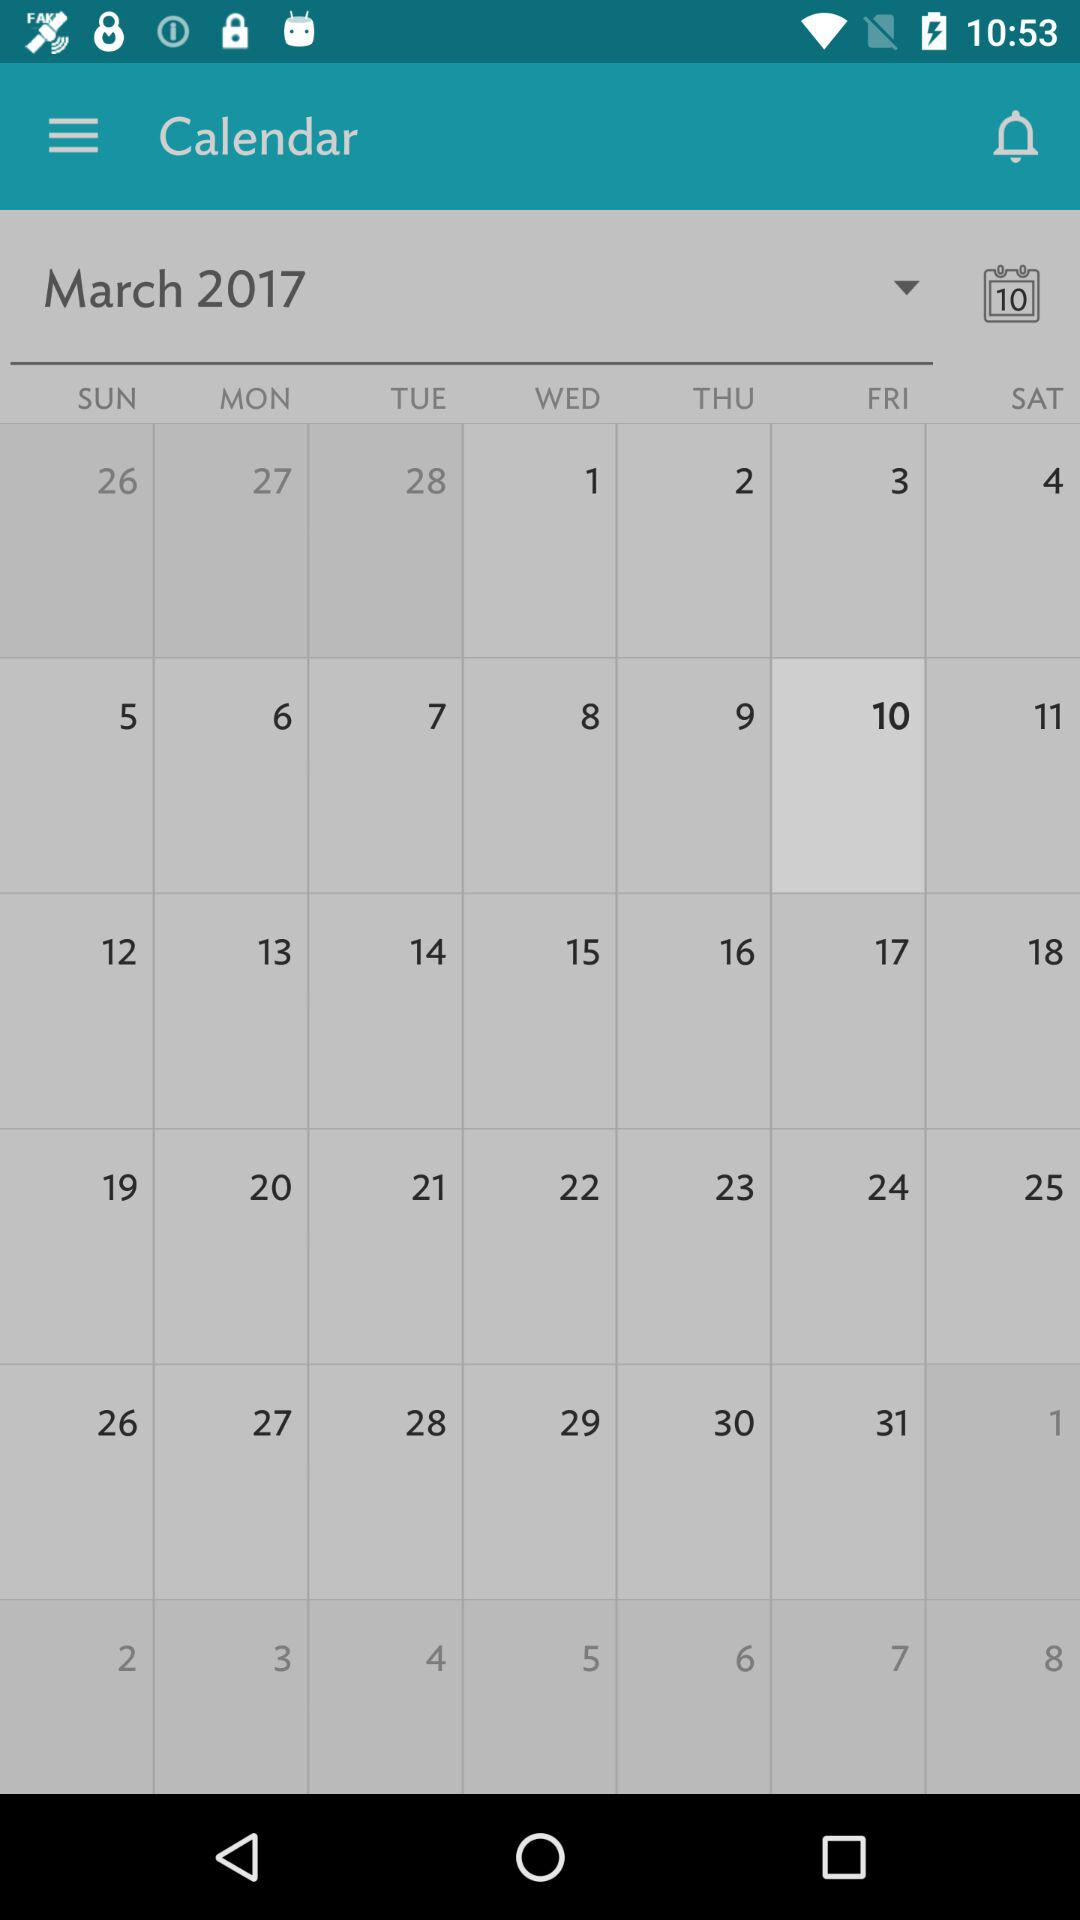What is the selected date? The selected date is Friday, March 10, 2017. 